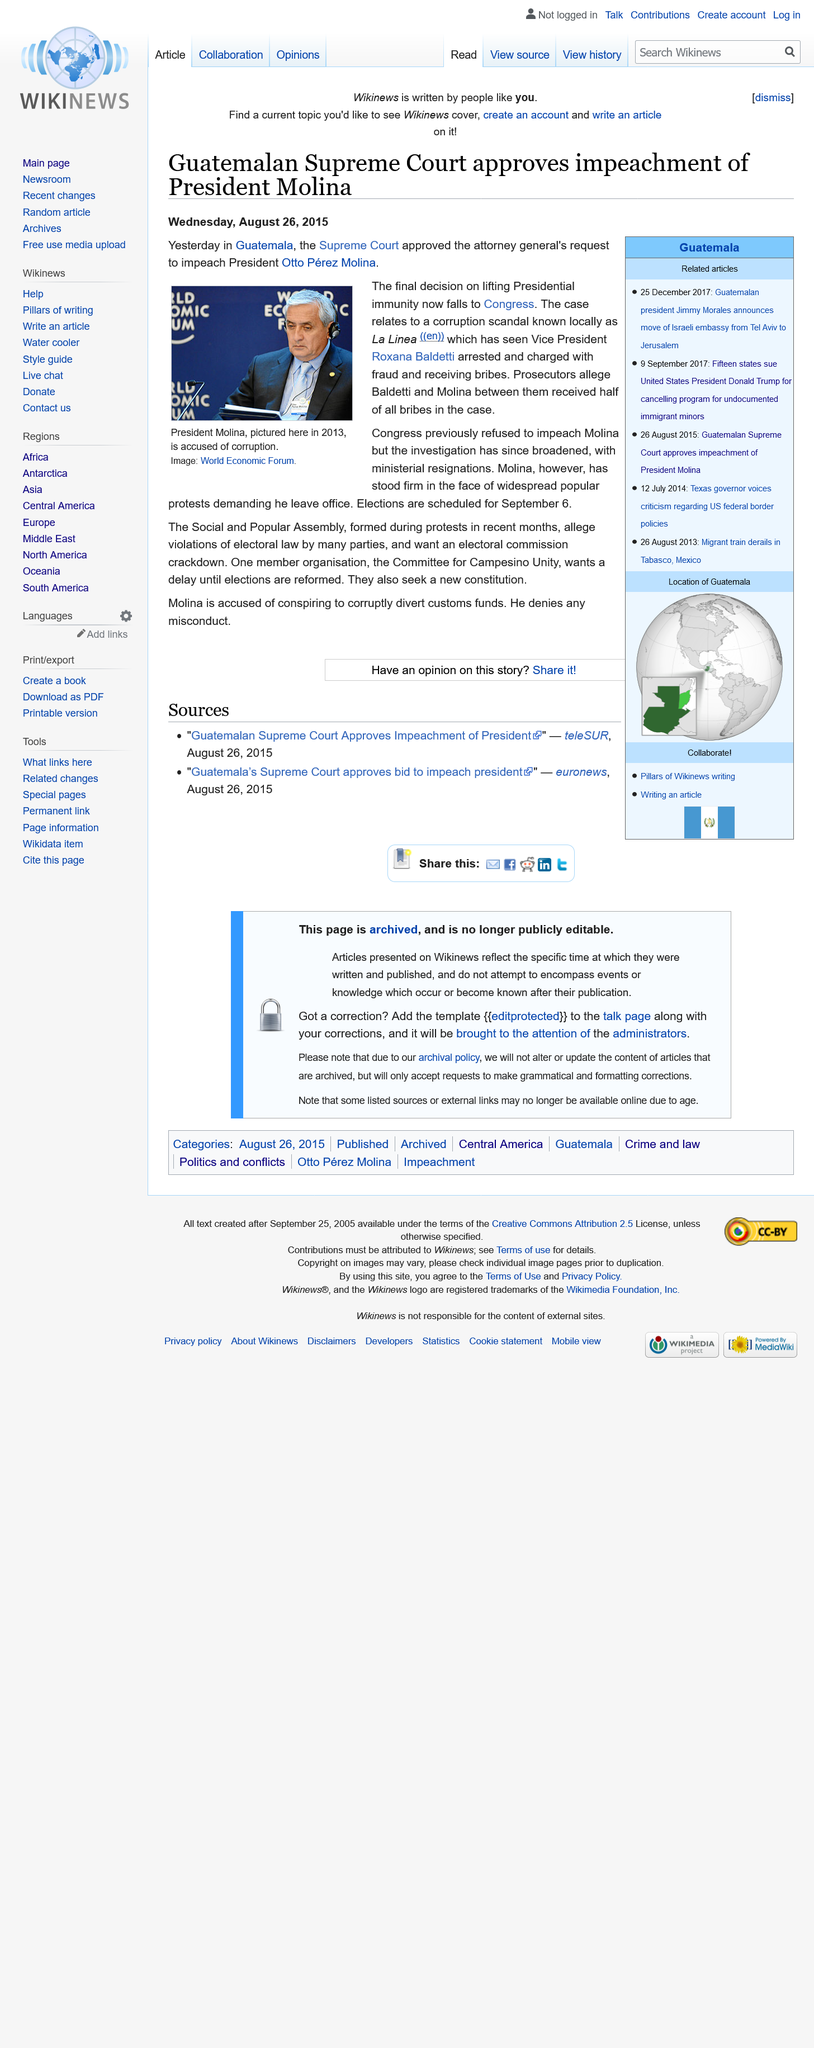List a handful of essential elements in this visual. La Linea, a corruption scandal that led to the impeachment of President Otto Perez Molina, is a well-known issue in local circles. Guatemalan Vice President Roxana Baldetti was implicated in the La Linea corruption scandal. On August 25th, 2015, Guatemalan President Otto Perez Molina was impeached due to corruption allegations. 